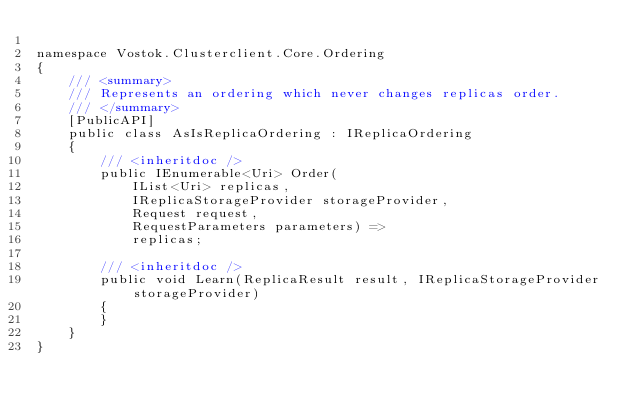<code> <loc_0><loc_0><loc_500><loc_500><_C#_>
namespace Vostok.Clusterclient.Core.Ordering
{
    /// <summary>
    /// Represents an ordering which never changes replicas order.
    /// </summary>
    [PublicAPI]
    public class AsIsReplicaOrdering : IReplicaOrdering
    {
        /// <inheritdoc />
        public IEnumerable<Uri> Order(
            IList<Uri> replicas,
            IReplicaStorageProvider storageProvider,
            Request request,
            RequestParameters parameters) =>
            replicas;

        /// <inheritdoc />
        public void Learn(ReplicaResult result, IReplicaStorageProvider storageProvider)
        {
        }
    }
}</code> 